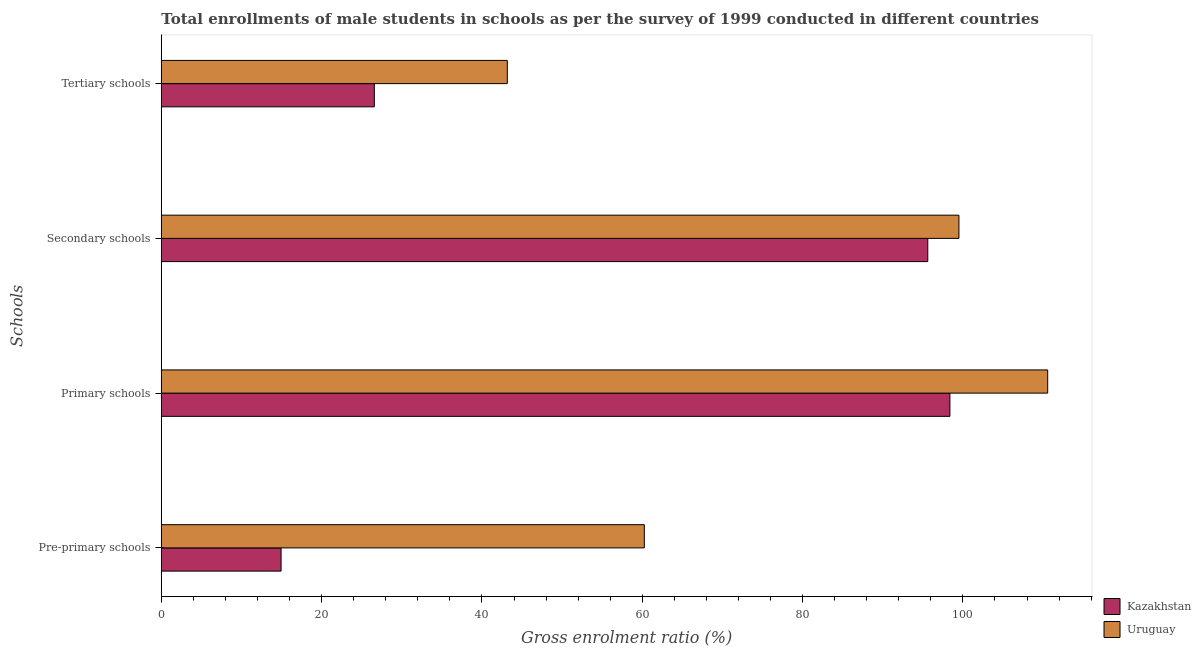How many groups of bars are there?
Offer a terse response. 4. Are the number of bars per tick equal to the number of legend labels?
Provide a short and direct response. Yes. How many bars are there on the 2nd tick from the top?
Make the answer very short. 2. How many bars are there on the 3rd tick from the bottom?
Offer a very short reply. 2. What is the label of the 4th group of bars from the top?
Your answer should be very brief. Pre-primary schools. What is the gross enrolment ratio(male) in primary schools in Uruguay?
Your response must be concise. 110.58. Across all countries, what is the maximum gross enrolment ratio(male) in pre-primary schools?
Keep it short and to the point. 60.26. Across all countries, what is the minimum gross enrolment ratio(male) in primary schools?
Offer a very short reply. 98.38. In which country was the gross enrolment ratio(male) in pre-primary schools maximum?
Offer a terse response. Uruguay. In which country was the gross enrolment ratio(male) in secondary schools minimum?
Make the answer very short. Kazakhstan. What is the total gross enrolment ratio(male) in primary schools in the graph?
Ensure brevity in your answer.  208.96. What is the difference between the gross enrolment ratio(male) in tertiary schools in Uruguay and that in Kazakhstan?
Your answer should be very brief. 16.59. What is the difference between the gross enrolment ratio(male) in primary schools in Uruguay and the gross enrolment ratio(male) in pre-primary schools in Kazakhstan?
Provide a succinct answer. 95.64. What is the average gross enrolment ratio(male) in primary schools per country?
Make the answer very short. 104.48. What is the difference between the gross enrolment ratio(male) in tertiary schools and gross enrolment ratio(male) in primary schools in Uruguay?
Your response must be concise. -67.42. What is the ratio of the gross enrolment ratio(male) in primary schools in Kazakhstan to that in Uruguay?
Keep it short and to the point. 0.89. Is the gross enrolment ratio(male) in pre-primary schools in Kazakhstan less than that in Uruguay?
Your answer should be very brief. Yes. What is the difference between the highest and the second highest gross enrolment ratio(male) in primary schools?
Offer a terse response. 12.2. What is the difference between the highest and the lowest gross enrolment ratio(male) in pre-primary schools?
Your answer should be compact. 45.32. In how many countries, is the gross enrolment ratio(male) in primary schools greater than the average gross enrolment ratio(male) in primary schools taken over all countries?
Make the answer very short. 1. Is the sum of the gross enrolment ratio(male) in secondary schools in Uruguay and Kazakhstan greater than the maximum gross enrolment ratio(male) in tertiary schools across all countries?
Your answer should be very brief. Yes. Is it the case that in every country, the sum of the gross enrolment ratio(male) in tertiary schools and gross enrolment ratio(male) in secondary schools is greater than the sum of gross enrolment ratio(male) in pre-primary schools and gross enrolment ratio(male) in primary schools?
Provide a succinct answer. No. What does the 1st bar from the top in Pre-primary schools represents?
Your answer should be compact. Uruguay. What does the 1st bar from the bottom in Secondary schools represents?
Your response must be concise. Kazakhstan. How many bars are there?
Give a very brief answer. 8. How many countries are there in the graph?
Provide a succinct answer. 2. Does the graph contain any zero values?
Your answer should be compact. No. What is the title of the graph?
Offer a terse response. Total enrollments of male students in schools as per the survey of 1999 conducted in different countries. What is the label or title of the X-axis?
Make the answer very short. Gross enrolment ratio (%). What is the label or title of the Y-axis?
Give a very brief answer. Schools. What is the Gross enrolment ratio (%) of Kazakhstan in Pre-primary schools?
Give a very brief answer. 14.94. What is the Gross enrolment ratio (%) in Uruguay in Pre-primary schools?
Provide a short and direct response. 60.26. What is the Gross enrolment ratio (%) of Kazakhstan in Primary schools?
Your answer should be very brief. 98.38. What is the Gross enrolment ratio (%) of Uruguay in Primary schools?
Offer a terse response. 110.58. What is the Gross enrolment ratio (%) of Kazakhstan in Secondary schools?
Your answer should be compact. 95.62. What is the Gross enrolment ratio (%) in Uruguay in Secondary schools?
Offer a very short reply. 99.51. What is the Gross enrolment ratio (%) of Kazakhstan in Tertiary schools?
Give a very brief answer. 26.58. What is the Gross enrolment ratio (%) in Uruguay in Tertiary schools?
Provide a succinct answer. 43.16. Across all Schools, what is the maximum Gross enrolment ratio (%) of Kazakhstan?
Ensure brevity in your answer.  98.38. Across all Schools, what is the maximum Gross enrolment ratio (%) of Uruguay?
Offer a very short reply. 110.58. Across all Schools, what is the minimum Gross enrolment ratio (%) of Kazakhstan?
Provide a succinct answer. 14.94. Across all Schools, what is the minimum Gross enrolment ratio (%) in Uruguay?
Your answer should be very brief. 43.16. What is the total Gross enrolment ratio (%) of Kazakhstan in the graph?
Your answer should be very brief. 235.52. What is the total Gross enrolment ratio (%) of Uruguay in the graph?
Ensure brevity in your answer.  313.51. What is the difference between the Gross enrolment ratio (%) of Kazakhstan in Pre-primary schools and that in Primary schools?
Offer a very short reply. -83.44. What is the difference between the Gross enrolment ratio (%) of Uruguay in Pre-primary schools and that in Primary schools?
Provide a short and direct response. -50.32. What is the difference between the Gross enrolment ratio (%) of Kazakhstan in Pre-primary schools and that in Secondary schools?
Give a very brief answer. -80.68. What is the difference between the Gross enrolment ratio (%) in Uruguay in Pre-primary schools and that in Secondary schools?
Your response must be concise. -39.25. What is the difference between the Gross enrolment ratio (%) of Kazakhstan in Pre-primary schools and that in Tertiary schools?
Ensure brevity in your answer.  -11.63. What is the difference between the Gross enrolment ratio (%) of Uruguay in Pre-primary schools and that in Tertiary schools?
Provide a short and direct response. 17.09. What is the difference between the Gross enrolment ratio (%) in Kazakhstan in Primary schools and that in Secondary schools?
Provide a succinct answer. 2.76. What is the difference between the Gross enrolment ratio (%) of Uruguay in Primary schools and that in Secondary schools?
Give a very brief answer. 11.07. What is the difference between the Gross enrolment ratio (%) in Kazakhstan in Primary schools and that in Tertiary schools?
Your answer should be compact. 71.81. What is the difference between the Gross enrolment ratio (%) of Uruguay in Primary schools and that in Tertiary schools?
Make the answer very short. 67.42. What is the difference between the Gross enrolment ratio (%) in Kazakhstan in Secondary schools and that in Tertiary schools?
Your answer should be very brief. 69.05. What is the difference between the Gross enrolment ratio (%) of Uruguay in Secondary schools and that in Tertiary schools?
Provide a short and direct response. 56.34. What is the difference between the Gross enrolment ratio (%) in Kazakhstan in Pre-primary schools and the Gross enrolment ratio (%) in Uruguay in Primary schools?
Keep it short and to the point. -95.64. What is the difference between the Gross enrolment ratio (%) of Kazakhstan in Pre-primary schools and the Gross enrolment ratio (%) of Uruguay in Secondary schools?
Ensure brevity in your answer.  -84.57. What is the difference between the Gross enrolment ratio (%) of Kazakhstan in Pre-primary schools and the Gross enrolment ratio (%) of Uruguay in Tertiary schools?
Give a very brief answer. -28.22. What is the difference between the Gross enrolment ratio (%) of Kazakhstan in Primary schools and the Gross enrolment ratio (%) of Uruguay in Secondary schools?
Offer a very short reply. -1.13. What is the difference between the Gross enrolment ratio (%) of Kazakhstan in Primary schools and the Gross enrolment ratio (%) of Uruguay in Tertiary schools?
Provide a succinct answer. 55.22. What is the difference between the Gross enrolment ratio (%) in Kazakhstan in Secondary schools and the Gross enrolment ratio (%) in Uruguay in Tertiary schools?
Give a very brief answer. 52.46. What is the average Gross enrolment ratio (%) of Kazakhstan per Schools?
Your answer should be very brief. 58.88. What is the average Gross enrolment ratio (%) of Uruguay per Schools?
Provide a succinct answer. 78.38. What is the difference between the Gross enrolment ratio (%) of Kazakhstan and Gross enrolment ratio (%) of Uruguay in Pre-primary schools?
Your answer should be very brief. -45.32. What is the difference between the Gross enrolment ratio (%) of Kazakhstan and Gross enrolment ratio (%) of Uruguay in Primary schools?
Your answer should be very brief. -12.2. What is the difference between the Gross enrolment ratio (%) in Kazakhstan and Gross enrolment ratio (%) in Uruguay in Secondary schools?
Your response must be concise. -3.89. What is the difference between the Gross enrolment ratio (%) in Kazakhstan and Gross enrolment ratio (%) in Uruguay in Tertiary schools?
Provide a succinct answer. -16.59. What is the ratio of the Gross enrolment ratio (%) in Kazakhstan in Pre-primary schools to that in Primary schools?
Provide a short and direct response. 0.15. What is the ratio of the Gross enrolment ratio (%) of Uruguay in Pre-primary schools to that in Primary schools?
Give a very brief answer. 0.54. What is the ratio of the Gross enrolment ratio (%) in Kazakhstan in Pre-primary schools to that in Secondary schools?
Your response must be concise. 0.16. What is the ratio of the Gross enrolment ratio (%) in Uruguay in Pre-primary schools to that in Secondary schools?
Keep it short and to the point. 0.61. What is the ratio of the Gross enrolment ratio (%) in Kazakhstan in Pre-primary schools to that in Tertiary schools?
Your answer should be compact. 0.56. What is the ratio of the Gross enrolment ratio (%) of Uruguay in Pre-primary schools to that in Tertiary schools?
Make the answer very short. 1.4. What is the ratio of the Gross enrolment ratio (%) of Kazakhstan in Primary schools to that in Secondary schools?
Your response must be concise. 1.03. What is the ratio of the Gross enrolment ratio (%) in Uruguay in Primary schools to that in Secondary schools?
Your answer should be compact. 1.11. What is the ratio of the Gross enrolment ratio (%) in Kazakhstan in Primary schools to that in Tertiary schools?
Ensure brevity in your answer.  3.7. What is the ratio of the Gross enrolment ratio (%) in Uruguay in Primary schools to that in Tertiary schools?
Ensure brevity in your answer.  2.56. What is the ratio of the Gross enrolment ratio (%) in Kazakhstan in Secondary schools to that in Tertiary schools?
Your answer should be very brief. 3.6. What is the ratio of the Gross enrolment ratio (%) of Uruguay in Secondary schools to that in Tertiary schools?
Your response must be concise. 2.31. What is the difference between the highest and the second highest Gross enrolment ratio (%) of Kazakhstan?
Your response must be concise. 2.76. What is the difference between the highest and the second highest Gross enrolment ratio (%) in Uruguay?
Provide a short and direct response. 11.07. What is the difference between the highest and the lowest Gross enrolment ratio (%) of Kazakhstan?
Your answer should be compact. 83.44. What is the difference between the highest and the lowest Gross enrolment ratio (%) in Uruguay?
Your answer should be very brief. 67.42. 